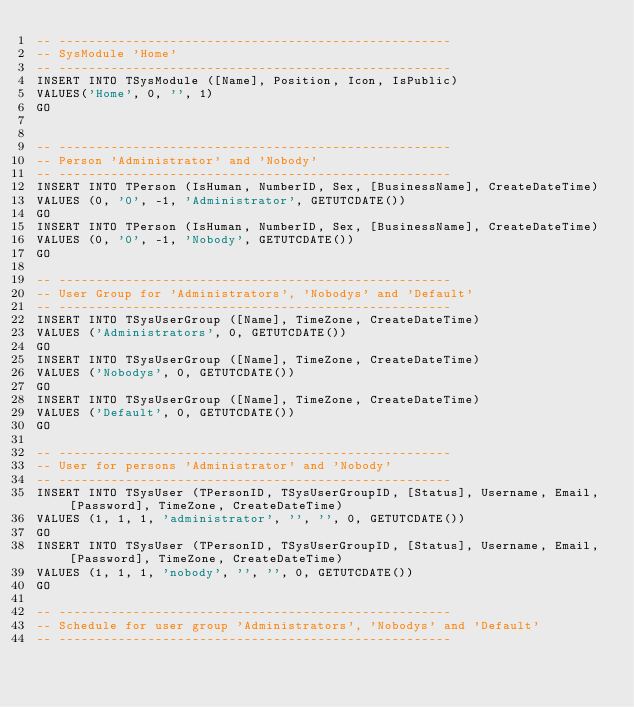Convert code to text. <code><loc_0><loc_0><loc_500><loc_500><_SQL_>-- -----------------------------------------------------
-- SysModule 'Home'
-- -----------------------------------------------------
INSERT INTO TSysModule ([Name], Position, Icon, IsPublic)
VALUES('Home', 0, '', 1)
GO


-- -----------------------------------------------------
-- Person 'Administrator' and 'Nobody'
-- -----------------------------------------------------
INSERT INTO TPerson (IsHuman, NumberID, Sex, [BusinessName], CreateDateTime)
VALUES (0, '0', -1, 'Administrator', GETUTCDATE())
GO
INSERT INTO TPerson (IsHuman, NumberID, Sex, [BusinessName], CreateDateTime)
VALUES (0, '0', -1, 'Nobody', GETUTCDATE())
GO

-- -----------------------------------------------------
-- User Group for 'Administrators', 'Nobodys' and 'Default'
-- -----------------------------------------------------
INSERT INTO TSysUserGroup ([Name], TimeZone, CreateDateTime)
VALUES ('Administrators', 0, GETUTCDATE())
GO
INSERT INTO TSysUserGroup ([Name], TimeZone, CreateDateTime)
VALUES ('Nobodys', 0, GETUTCDATE())
GO
INSERT INTO TSysUserGroup ([Name], TimeZone, CreateDateTime)
VALUES ('Default', 0, GETUTCDATE())
GO

-- -----------------------------------------------------
-- User for persons 'Administrator' and 'Nobody'
-- -----------------------------------------------------
INSERT INTO TSysUser (TPersonID, TSysUserGroupID, [Status], Username, Email, [Password], TimeZone, CreateDateTime)
VALUES (1, 1, 1, 'administrator', '', '', 0, GETUTCDATE())
GO
INSERT INTO TSysUser (TPersonID, TSysUserGroupID, [Status], Username, Email, [Password], TimeZone, CreateDateTime)
VALUES (1, 1, 1, 'nobody', '', '', 0, GETUTCDATE())
GO

-- -----------------------------------------------------
-- Schedule for user group 'Administrators', 'Nobodys' and 'Default'
-- -----------------------------------------------------</code> 